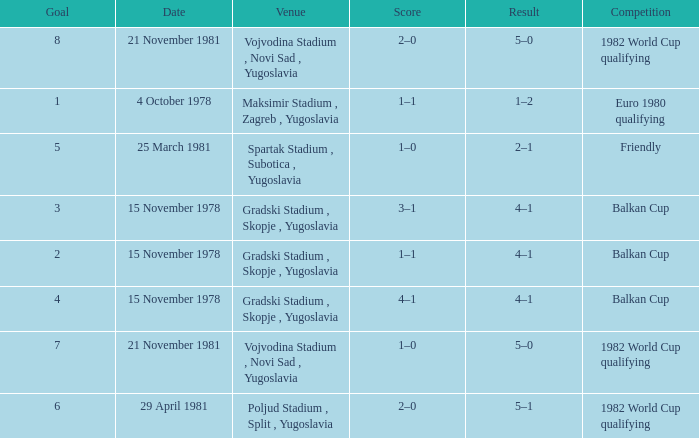What is the consequence of reaching goal 3? 4–1. 